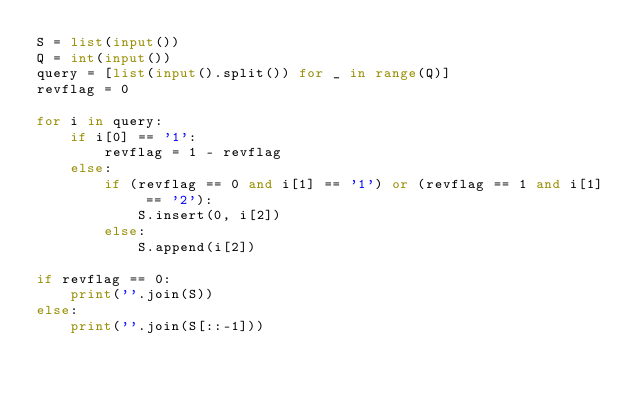<code> <loc_0><loc_0><loc_500><loc_500><_Python_>S = list(input())
Q = int(input())
query = [list(input().split()) for _ in range(Q)]
revflag = 0

for i in query:
    if i[0] == '1':
        revflag = 1 - revflag
    else:
        if (revflag == 0 and i[1] == '1') or (revflag == 1 and i[1] == '2'):
            S.insert(0, i[2])
        else:
            S.append(i[2])

if revflag == 0:
    print(''.join(S))
else:
    print(''.join(S[::-1]))</code> 